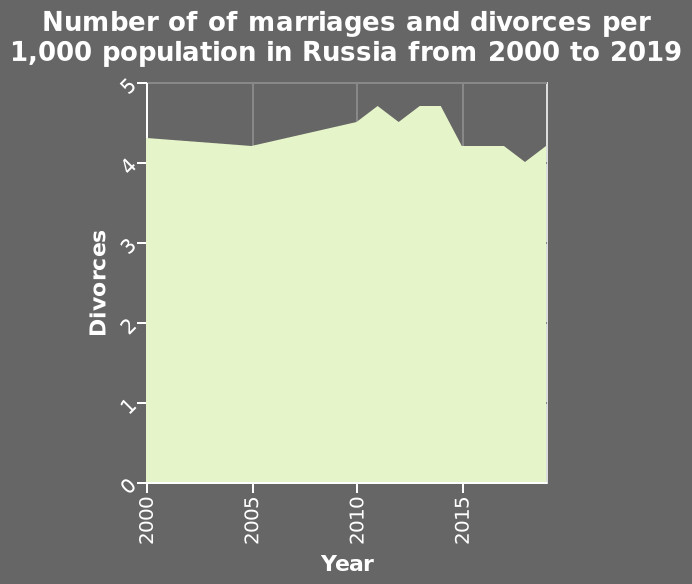<image>
Is the number of marriages and divorces higher now compared to 2017? Yes, the number of marriages and divorces has increased since 2017. Has the trend for marriages and divorces been increasing in recent years? Yes, the trend for marriages and divorces has slowly started to increase in recent years. please enumerates aspects of the construction of the chart Number of of marriages and divorces per 1,000 population in Russia from 2000 to 2019 is a area plot. Along the x-axis, Year is defined on a linear scale from 2000 to 2015. On the y-axis, Divorces is defined along a linear scale of range 0 to 5. please summary the statistics and relations of the chart The number of divorces dropped sharply in 2014. Divorces continued to drop through 2015 but started to rise towards the end of the year. The number of divorces dtayed static at the start of the decade. Has the number of marriages and divorces decreased since 2017? No.Yes, the number of marriages and divorces has increased since 2017. 